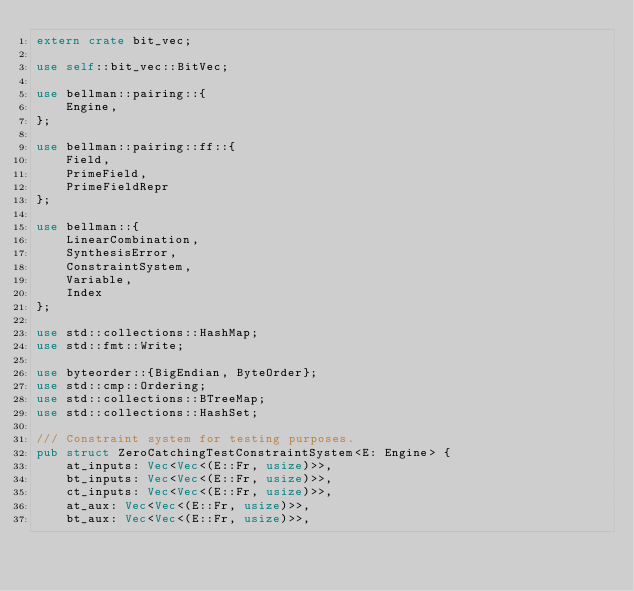Convert code to text. <code><loc_0><loc_0><loc_500><loc_500><_Rust_>extern crate bit_vec;

use self::bit_vec::BitVec;

use bellman::pairing::{
    Engine,
};

use bellman::pairing::ff::{
    Field,
    PrimeField,
    PrimeFieldRepr
};

use bellman::{
    LinearCombination,
    SynthesisError,
    ConstraintSystem,
    Variable,
    Index
};

use std::collections::HashMap;
use std::fmt::Write;

use byteorder::{BigEndian, ByteOrder};
use std::cmp::Ordering;
use std::collections::BTreeMap;
use std::collections::HashSet;

/// Constraint system for testing purposes.
pub struct ZeroCatchingTestConstraintSystem<E: Engine> {
    at_inputs: Vec<Vec<(E::Fr, usize)>>,
    bt_inputs: Vec<Vec<(E::Fr, usize)>>,
    ct_inputs: Vec<Vec<(E::Fr, usize)>>,
    at_aux: Vec<Vec<(E::Fr, usize)>>,
    bt_aux: Vec<Vec<(E::Fr, usize)>>,</code> 